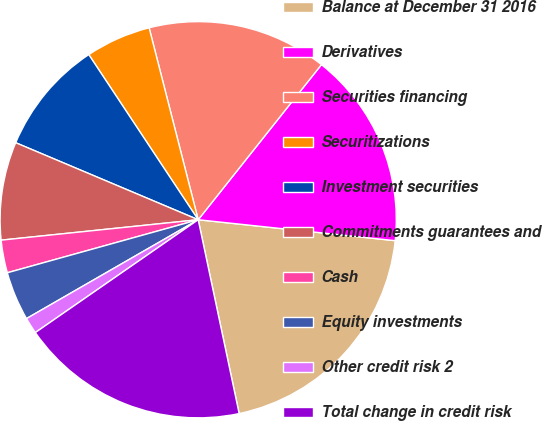Convert chart. <chart><loc_0><loc_0><loc_500><loc_500><pie_chart><fcel>Balance at December 31 2016<fcel>Derivatives<fcel>Securities financing<fcel>Securitizations<fcel>Investment securities<fcel>Commitments guarantees and<fcel>Cash<fcel>Equity investments<fcel>Other credit risk 2<fcel>Total change in credit risk<nl><fcel>20.0%<fcel>16.0%<fcel>14.67%<fcel>5.33%<fcel>9.33%<fcel>8.0%<fcel>2.67%<fcel>4.0%<fcel>1.33%<fcel>18.67%<nl></chart> 